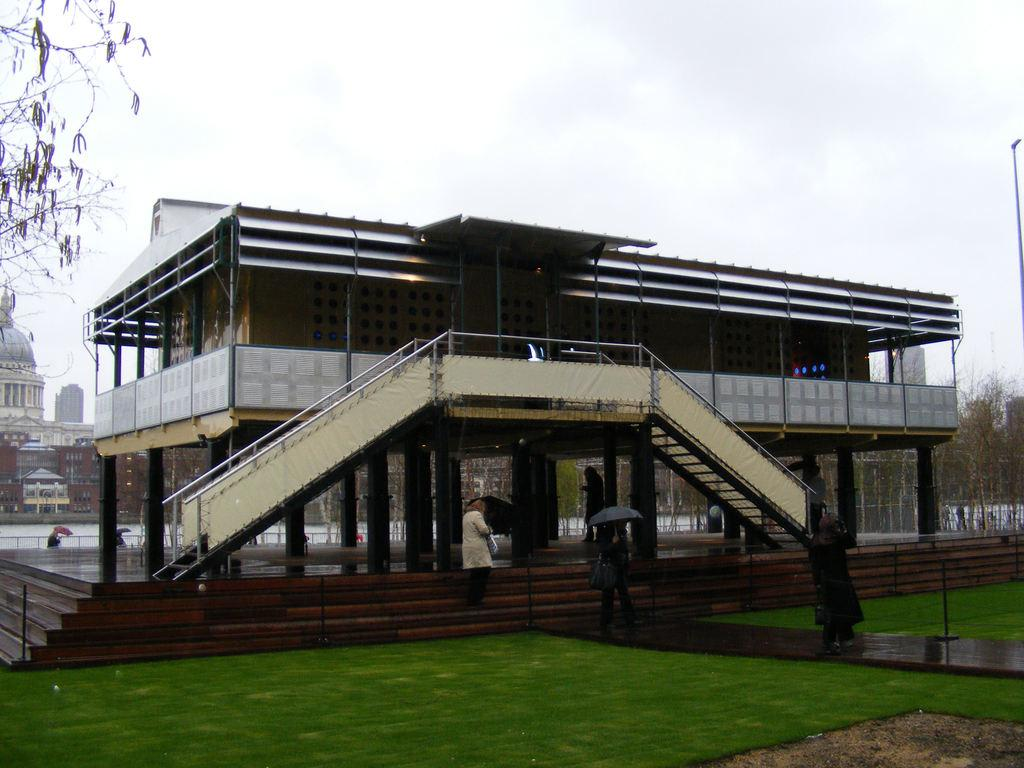What type of vegetation is present in the image? There is grass in the image. What type of structures can be seen in the image? There are buildings in the image. What other natural elements are present in the image? There are trees in the image. What are the people in the image doing? Most of the people are standing and holding umbrellas. What is visible in the background of the image? The sky is visible in the background of the image. Can you see a crown on the head of any person in the image? There is no crown visible on any person's head in the image. Are there any geese present in the image? There are no geese present in the image. 